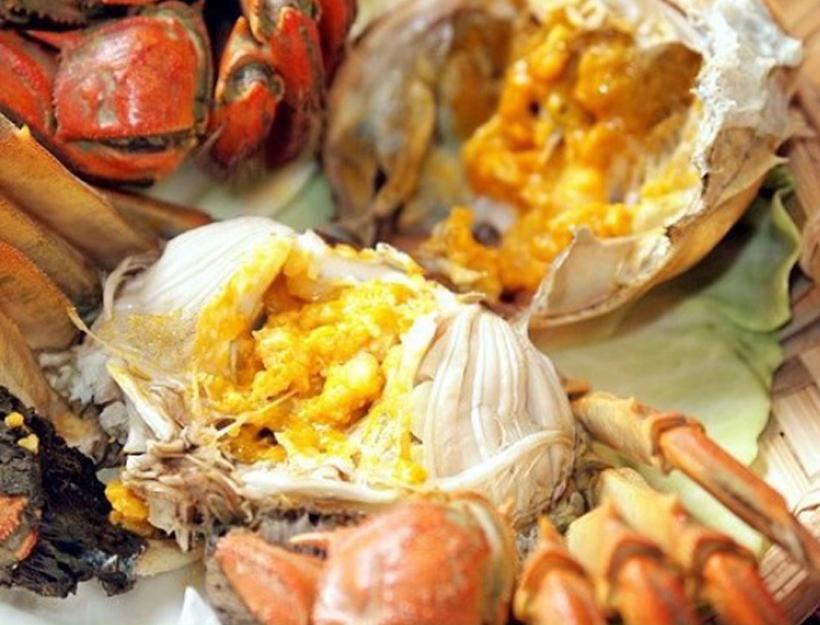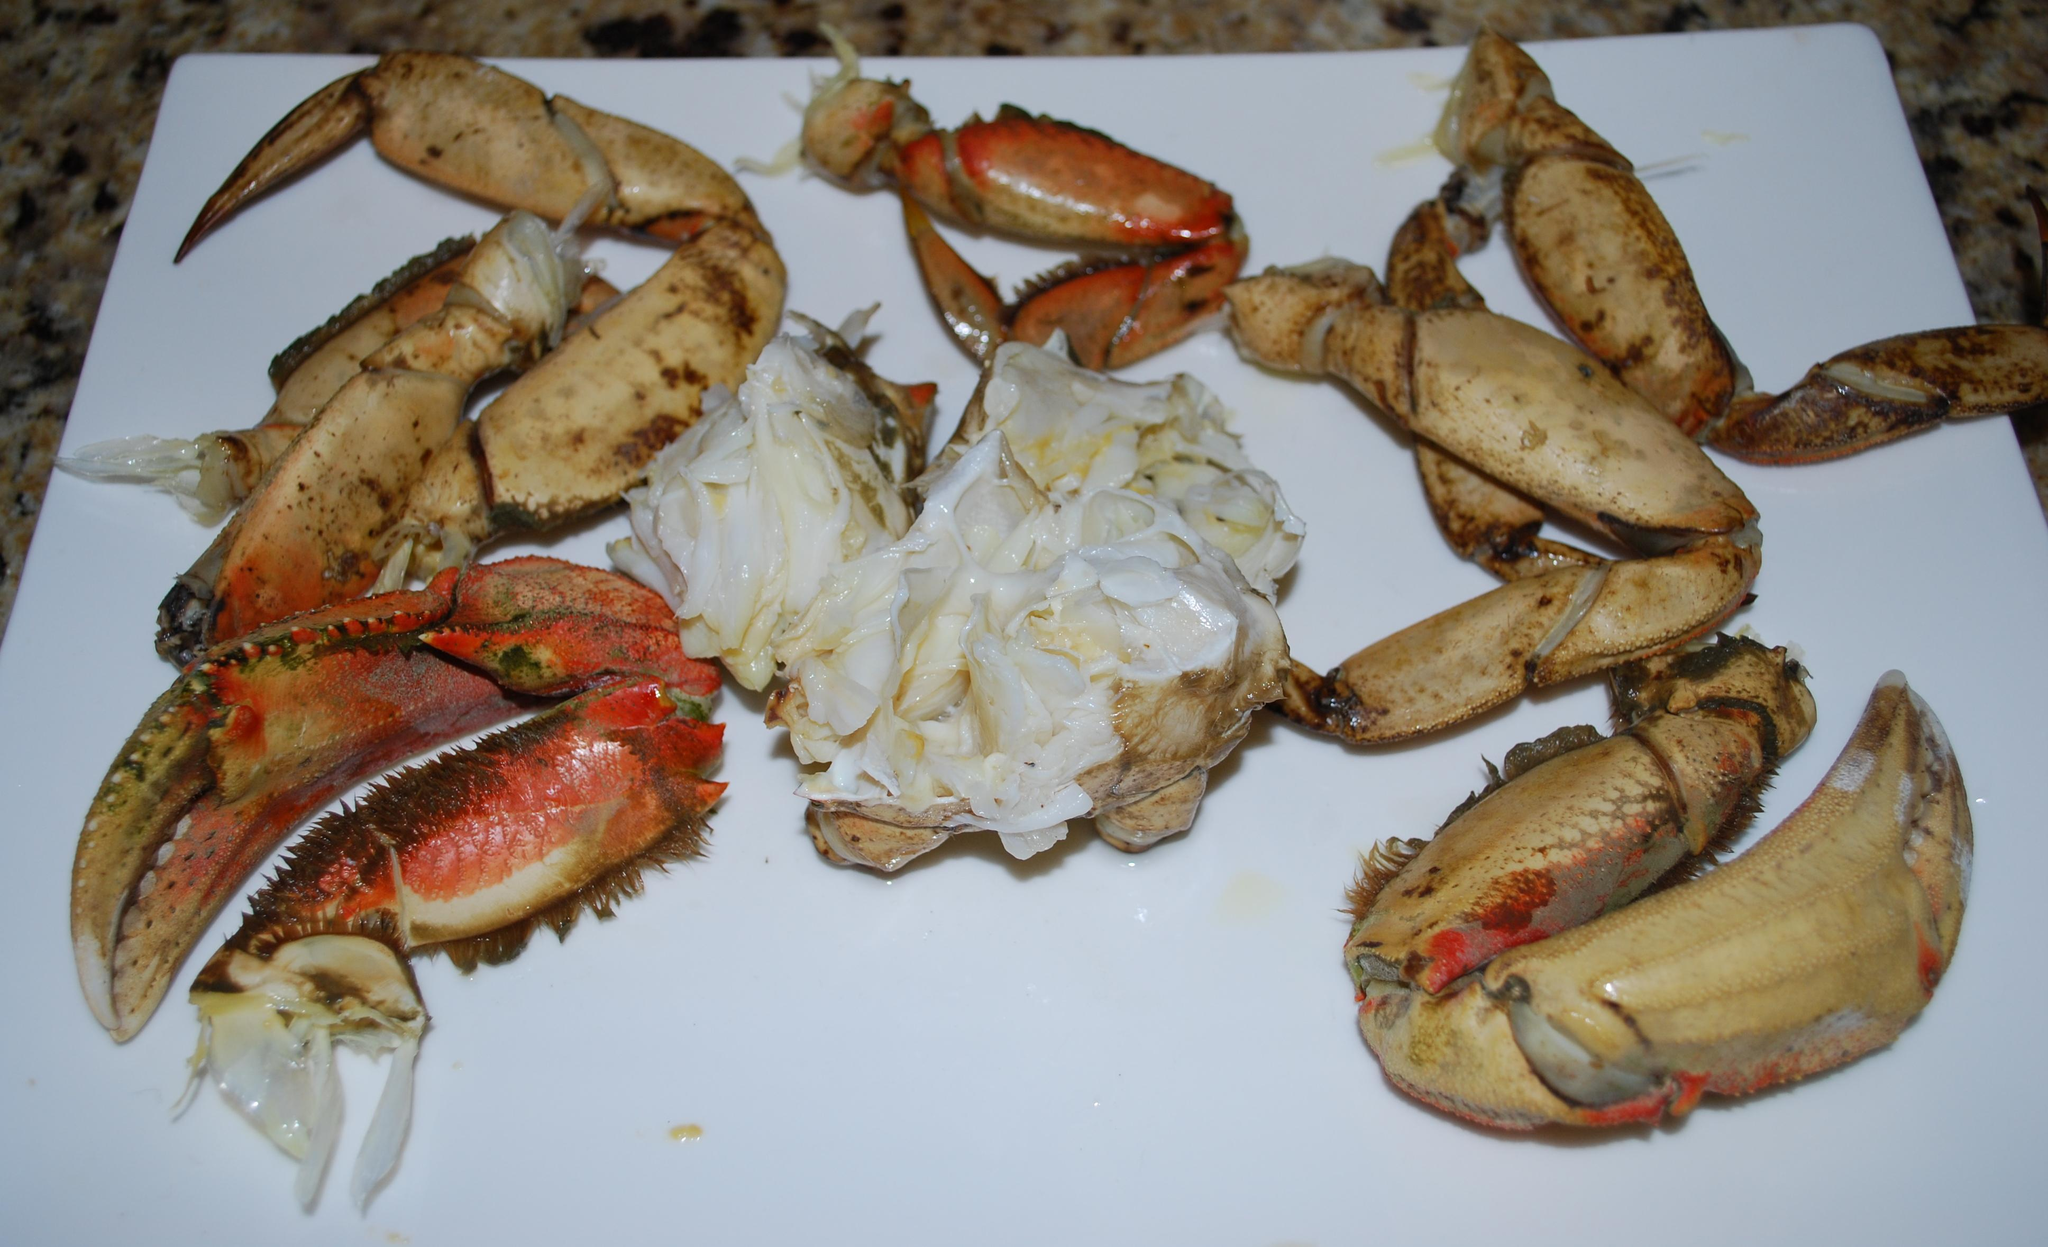The first image is the image on the left, the second image is the image on the right. Assess this claim about the two images: "A person is holding up the crab in the image on the left.". Correct or not? Answer yes or no. No. The first image is the image on the left, the second image is the image on the right. Assess this claim about the two images: "A hand is holding onto a crab in at least one image, and a crab is on a wooden board in the right image.". Correct or not? Answer yes or no. No. 